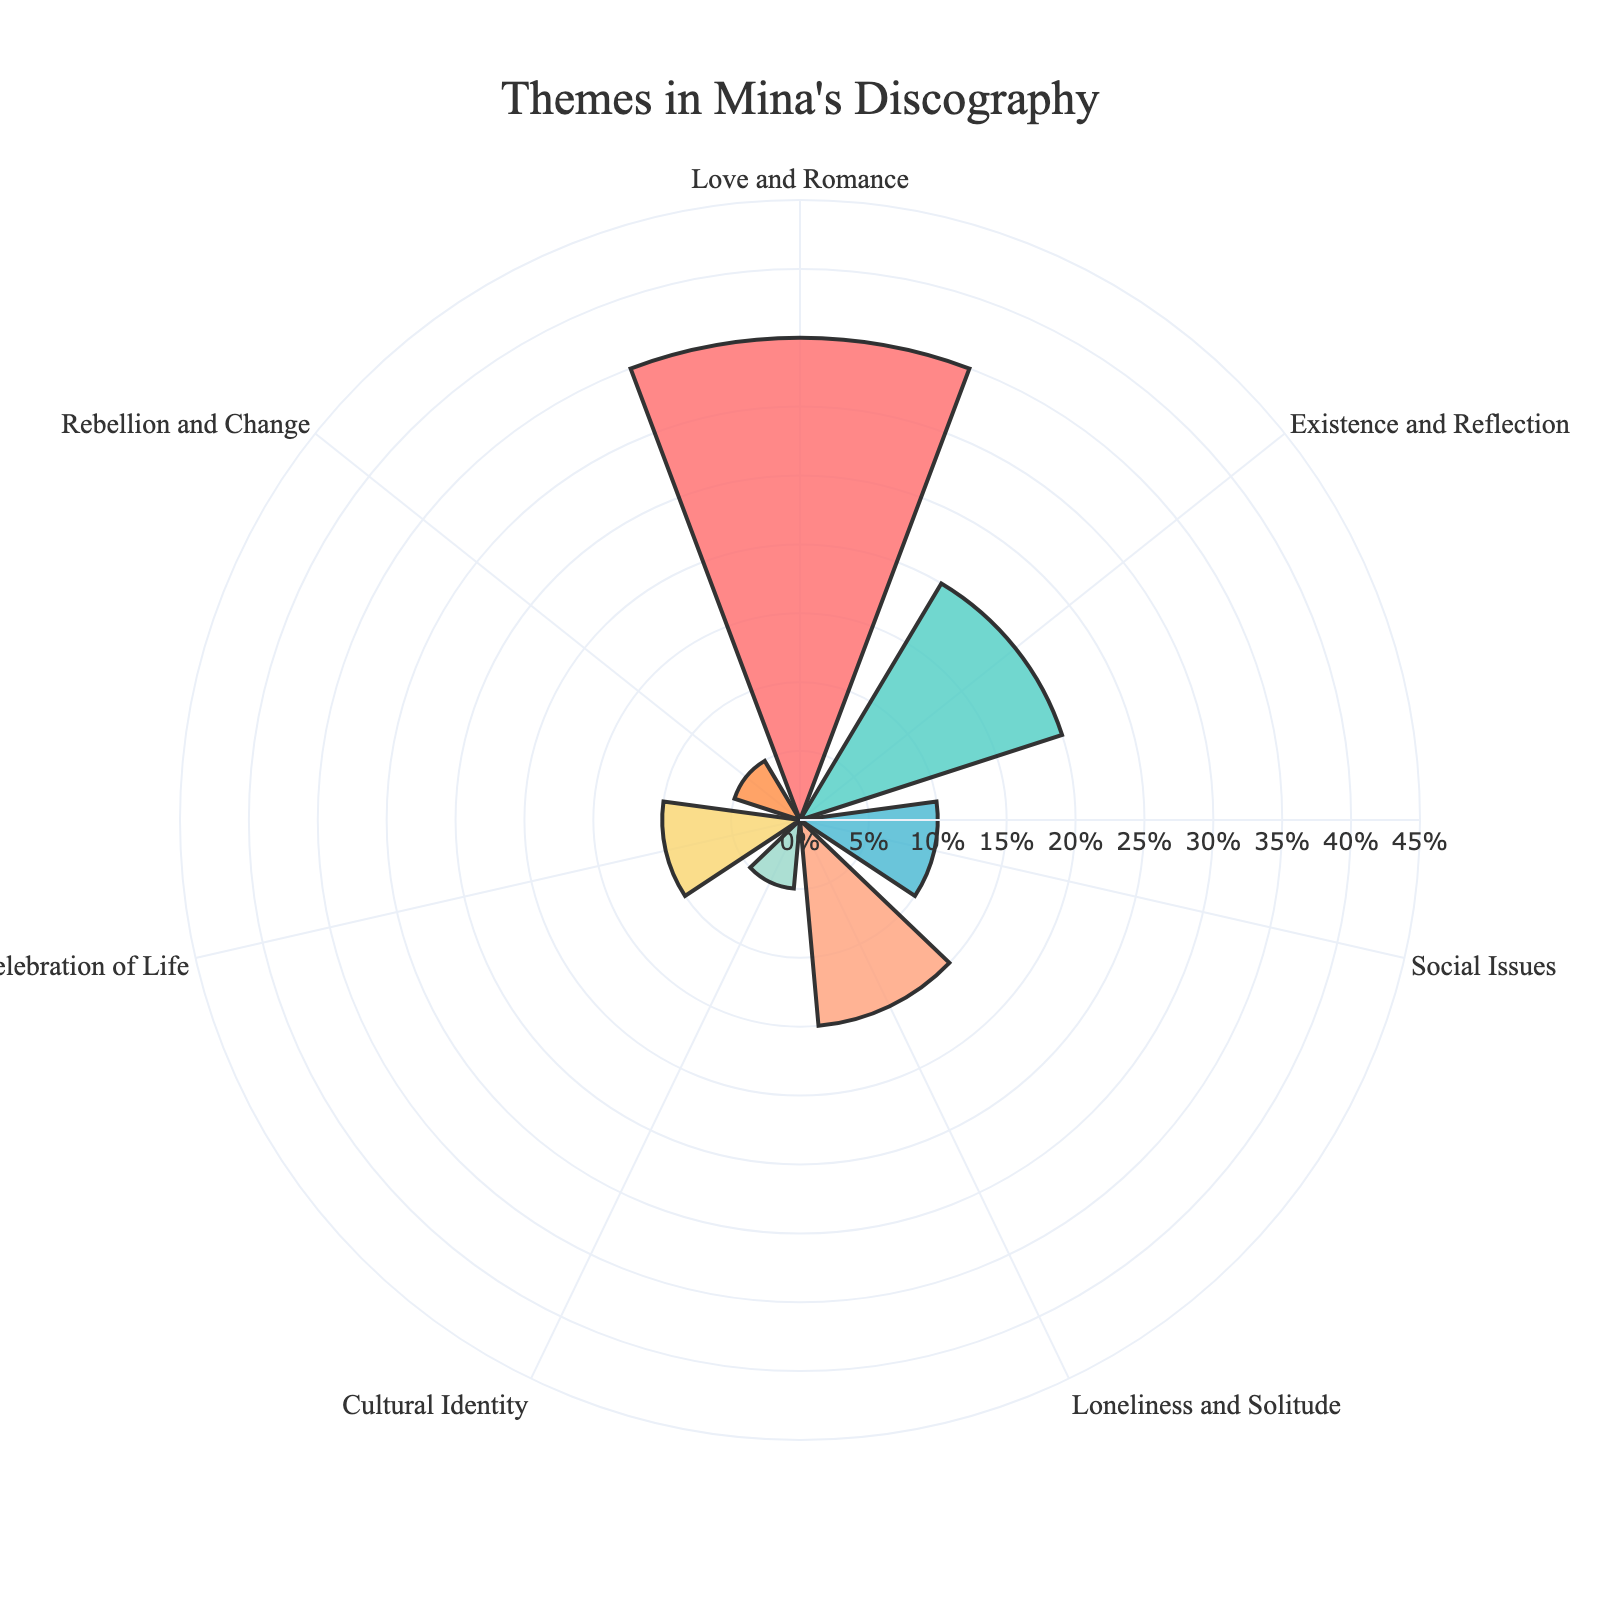What is the title of the plot? The title is the text that appears at the top of the plot, which summarizes the main idea of the chart. By looking at the top-center of the plot, we can see the title.
Answer: Themes in Mina's Discography Which theme has the highest percentage? By observing the lengths of the bars in the rose chart, we can see that the theme with the longest bar represents the highest percentage.
Answer: Love and Romance What is the percentage of themes related to Loneliness and Solitude? We can find the percentage by looking at the label corresponding to the theme "Loneliness and Solitude" and reading the value indicated by its bar.
Answer: 15% Which theme has a lower percentage: Cultural Identity or Rebellion and Change? We compare the lengths of the bars for "Cultural Identity" and "Rebellion and Change". Both themes have small bars, but we need the exact values to determine the answer.
Answer: Tie (both 5%) How many themes have a percentage of 10% or higher? To solve this, count the number of bars that have a length or percentage value of 10% or above.
Answer: 4 themes What are the combined percentages of Love and Romance, and Celebration of Life? Sum the percentages of "Love and Romance" (35%) and "Celebration of Life" (10%). 35% + 10% = 45%
Answer: 45% Which themes have an equal percentage? We look for bars with the same length or the same percentage value.
Answer: Cultural Identity and Rebellion and Change (both 5%) What is the difference in percentage between Existence and Reflection and Loneliness and Solitude? Subtract the percentage of "Loneliness and Solitude" (15%) from that of "Existence and Reflection" (20%). 20% - 15% = 5%
Answer: 5% Among Love and Romance, Cultural Identity, and Social Issues, which has the smallest percentage? Compare the percentages of the three themes mentioned: "Love and Romance" (35%), "Cultural Identity" (5%), and "Social Issues" (10%).
Answer: Cultural Identity If we include only the themes with percentages of 10% or greater, which themes remain? Filter the themes to include only those with percentages equal to or higher than 10%. This leaves us with "Love and Romance" (35%), "Existence and Reflection" (20%), "Social Issues" (10%), "Loneliness and Solitude" (15%), and "Celebration of Life" (10%).
Answer: Love and Romance, Existence and Reflection, Social Issues, Loneliness and Solitude, Celebration of Life 